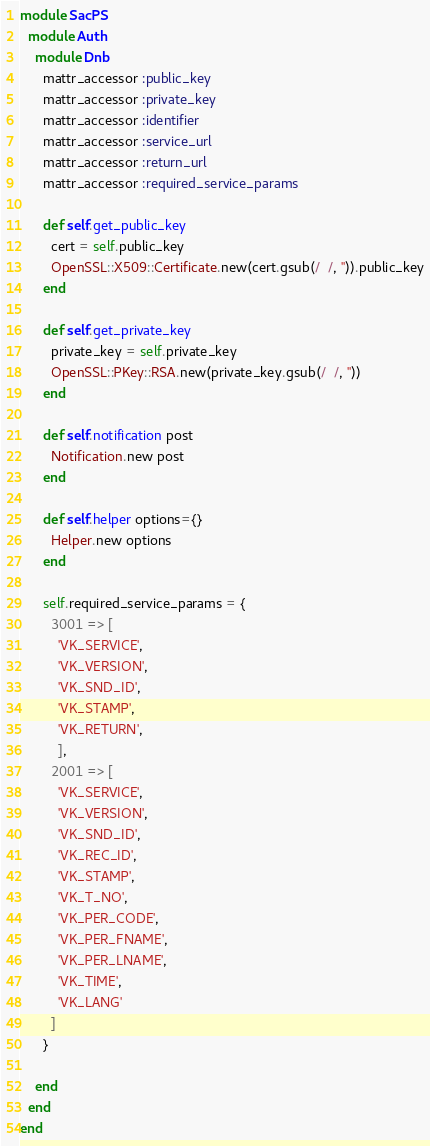Convert code to text. <code><loc_0><loc_0><loc_500><loc_500><_Ruby_>
module SacPS
  module Auth
    module Dnb
      mattr_accessor :public_key
      mattr_accessor :private_key
      mattr_accessor :identifier
      mattr_accessor :service_url
      mattr_accessor :return_url
      mattr_accessor :required_service_params

      def self.get_public_key
        cert = self.public_key
        OpenSSL::X509::Certificate.new(cert.gsub(/  /, '')).public_key
      end

      def self.get_private_key
        private_key = self.private_key
        OpenSSL::PKey::RSA.new(private_key.gsub(/  /, ''))
      end

      def self.notification post
        Notification.new post
      end

      def self.helper options={}
        Helper.new options
      end

      self.required_service_params = {
        3001 => [
          'VK_SERVICE',
          'VK_VERSION',
          'VK_SND_ID',
          'VK_STAMP',
          'VK_RETURN',
          ],
        2001 => [
          'VK_SERVICE',
          'VK_VERSION',
          'VK_SND_ID',
          'VK_REC_ID',
          'VK_STAMP',
          'VK_T_NO',
          'VK_PER_CODE',
          'VK_PER_FNAME',
          'VK_PER_LNAME',
          'VK_TIME',
          'VK_LANG'
        ]
      }

    end
  end
end</code> 